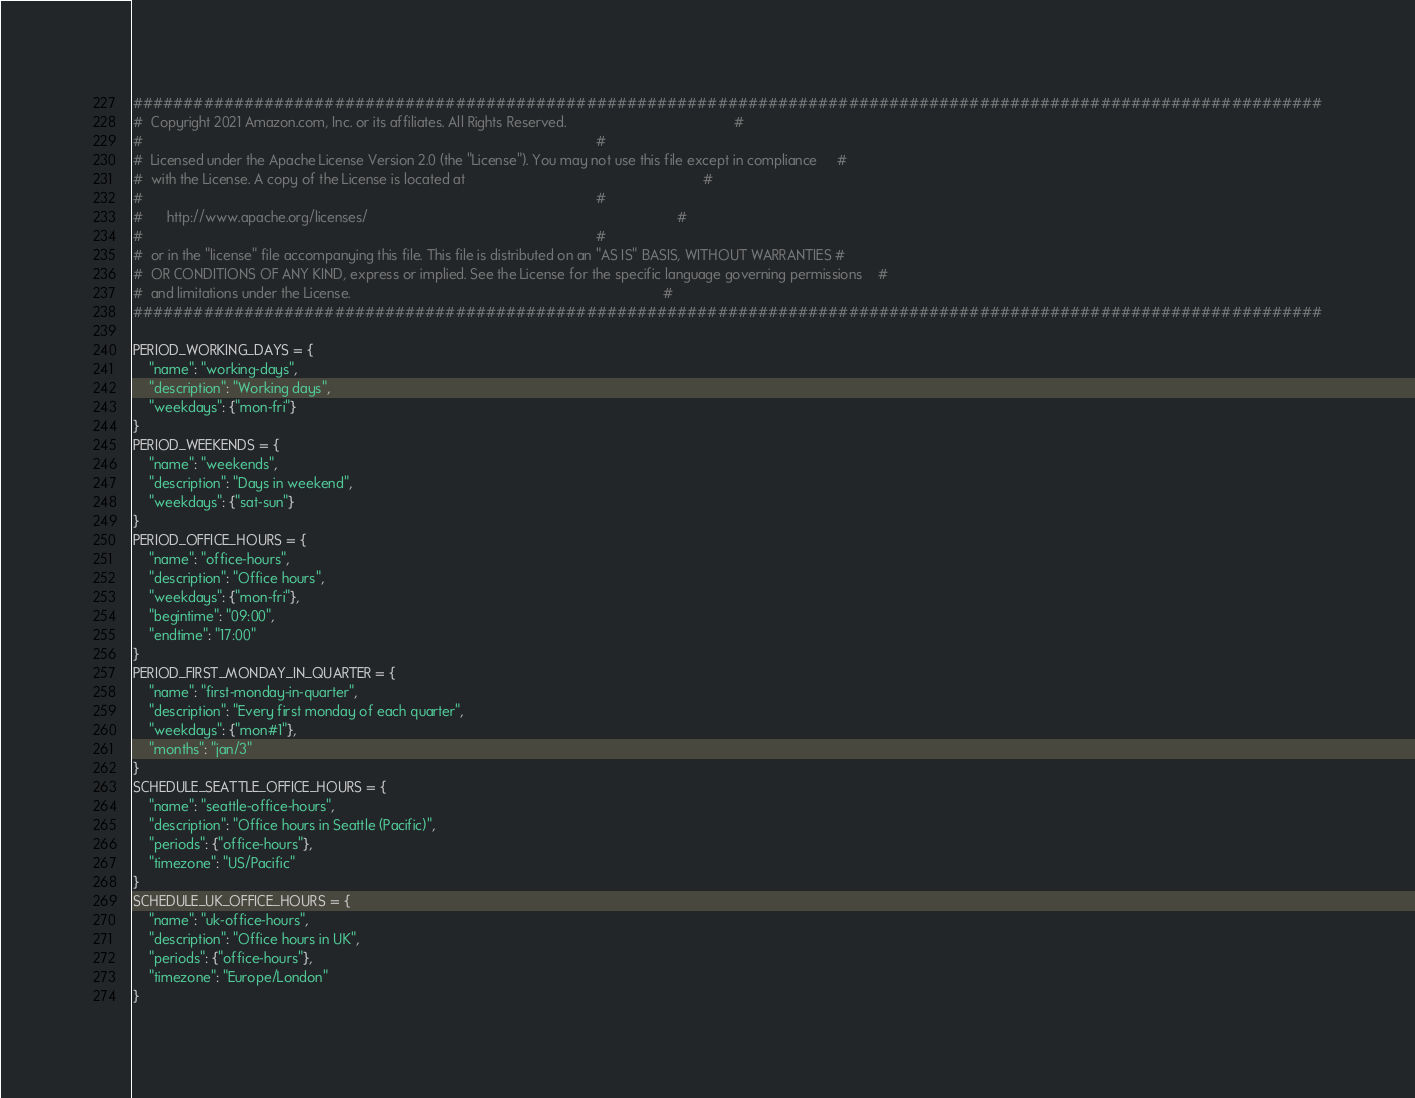<code> <loc_0><loc_0><loc_500><loc_500><_Python_>######################################################################################################################
#  Copyright 2021 Amazon.com, Inc. or its affiliates. All Rights Reserved.                                           #
#                                                                                                                    #
#  Licensed under the Apache License Version 2.0 (the "License"). You may not use this file except in compliance     #
#  with the License. A copy of the License is located at                                                             #
#                                                                                                                    #
#      http://www.apache.org/licenses/                                                                               #
#                                                                                                                    #
#  or in the "license" file accompanying this file. This file is distributed on an "AS IS" BASIS, WITHOUT WARRANTIES #
#  OR CONDITIONS OF ANY KIND, express or implied. See the License for the specific language governing permissions    #
#  and limitations under the License.                                                                                #
######################################################################################################################

PERIOD_WORKING_DAYS = {
    "name": "working-days",
    "description": "Working days",
    "weekdays": {"mon-fri"}
}
PERIOD_WEEKENDS = {
    "name": "weekends",
    "description": "Days in weekend",
    "weekdays": {"sat-sun"}
}
PERIOD_OFFICE_HOURS = {
    "name": "office-hours",
    "description": "Office hours",
    "weekdays": {"mon-fri"},
    "begintime": "09:00",
    "endtime": "17:00"
}
PERIOD_FIRST_MONDAY_IN_QUARTER = {
    "name": "first-monday-in-quarter",
    "description": "Every first monday of each quarter",
    "weekdays": {"mon#1"},
    "months": "jan/3"
}
SCHEDULE_SEATTLE_OFFICE_HOURS = {
    "name": "seattle-office-hours",
    "description": "Office hours in Seattle (Pacific)",
    "periods": {"office-hours"},
    "timezone": "US/Pacific"
}
SCHEDULE_UK_OFFICE_HOURS = {
    "name": "uk-office-hours",
    "description": "Office hours in UK",
    "periods": {"office-hours"},
    "timezone": "Europe/London"
}
</code> 